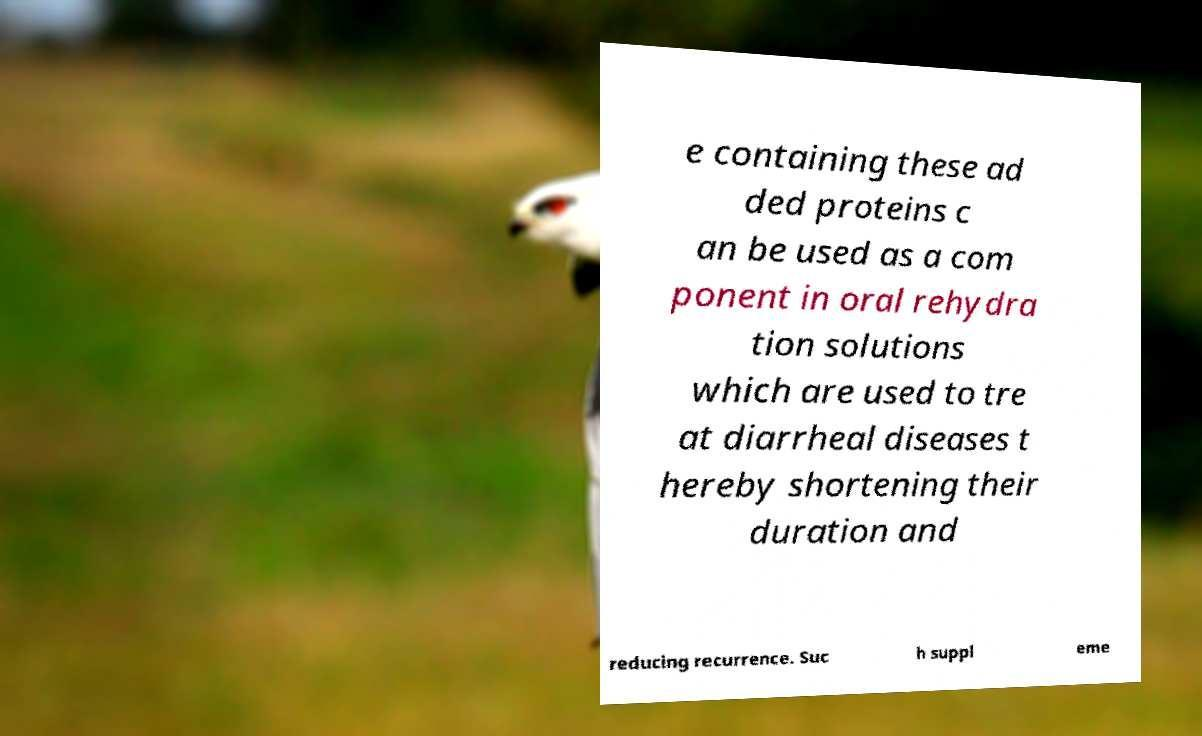I need the written content from this picture converted into text. Can you do that? e containing these ad ded proteins c an be used as a com ponent in oral rehydra tion solutions which are used to tre at diarrheal diseases t hereby shortening their duration and reducing recurrence. Suc h suppl eme 